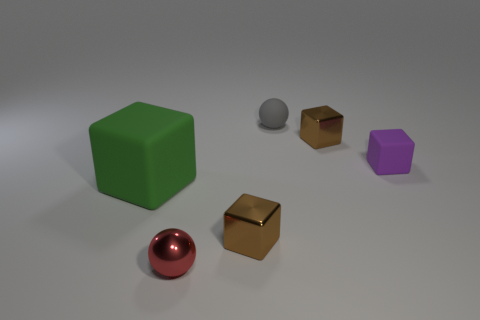How many objects are there in total, and can you describe their colors? There are five objects in the image. Starting from the left, there's a shiny red sphere, a large green cube, a small silver sphere, a small gold cube, and a small purple cube. Which object stands out the most to you? The shiny red sphere stands out the most due to its vibrant color and reflective surface that contrasts with the matte finishes of the other objects. 